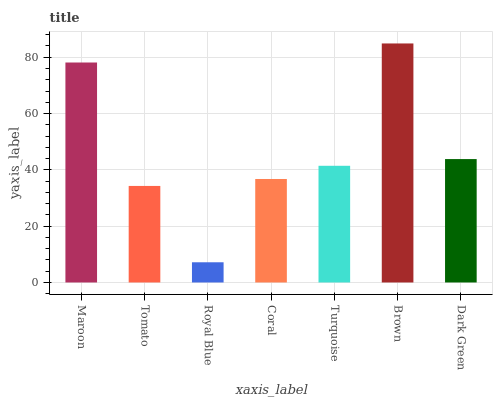Is Royal Blue the minimum?
Answer yes or no. Yes. Is Brown the maximum?
Answer yes or no. Yes. Is Tomato the minimum?
Answer yes or no. No. Is Tomato the maximum?
Answer yes or no. No. Is Maroon greater than Tomato?
Answer yes or no. Yes. Is Tomato less than Maroon?
Answer yes or no. Yes. Is Tomato greater than Maroon?
Answer yes or no. No. Is Maroon less than Tomato?
Answer yes or no. No. Is Turquoise the high median?
Answer yes or no. Yes. Is Turquoise the low median?
Answer yes or no. Yes. Is Brown the high median?
Answer yes or no. No. Is Coral the low median?
Answer yes or no. No. 